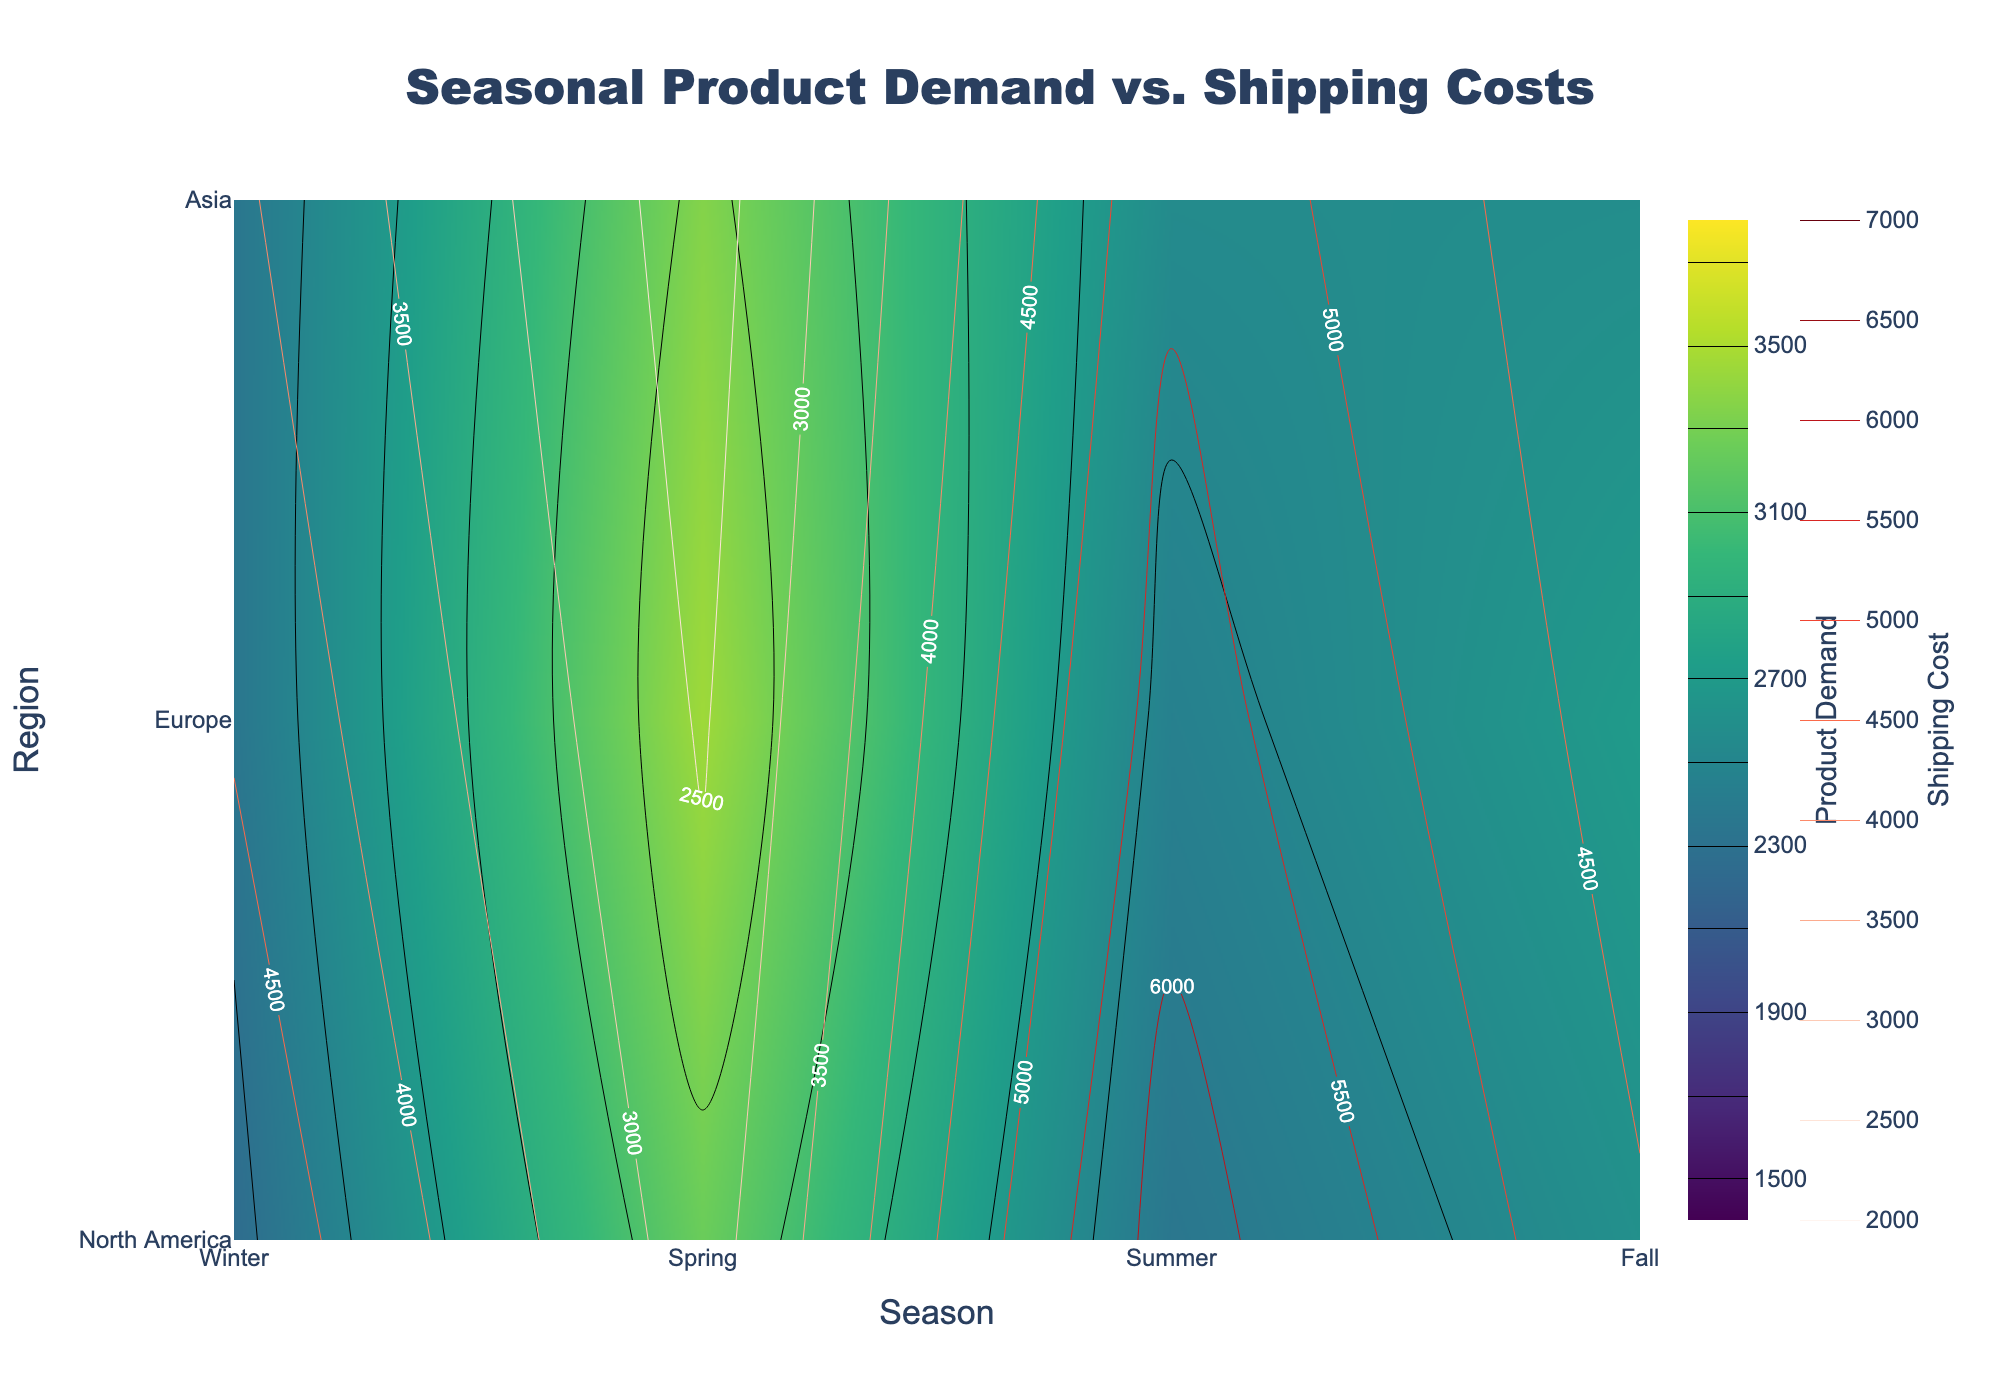What's the title of the figure? The title of the figure is prominently displayed at the top and reads "Seasonal Product Demand vs. Shipping Costs".
Answer: Seasonal Product Demand vs. Shipping Costs Which region shows the highest average product demand in winter? To find the highest average product demand in winter, look at the 'Winter' column and compare the values across regions. Asia shows the highest demand in winter.
Answer: Asia What is the average shipping cost for Europe during spring? To determine the average shipping cost for Europe during spring, find the value in the ‘Spring’ column for the ‘Europe’ row in the contour plot representing shipping costs. The average shipping cost is 2450.
Answer: 2450 Which season has the lowest product demand in North America? Look at the 'North America' row and compare the product demand values across all seasons. Summer has the lowest product demand.
Answer: Summer Compare the average product demand in Asia during winter and summer. Which is higher? Locate the 'Asia' row and compare the product demands during winter and summer. The winter demand (2350) is higher than the summer demand (2550).
Answer: Winter What are the contour line intervals for shipping costs on the plot? Refer to the contour plot details for shipping costs; lines are drawn at intervals of 500 units, starting from 2000 up to 7000.
Answer: 500 units During which season and in which region is the product demand the lowest? Examine the entire contour plot for product demand. The lowest value is during summer in North America, with a demand of 1500.
Answer: Summer in North America Compare and contrast the product demand for ‘Outdoor Furniture’ in Europe during spring with ‘Leaf Blowers’ in North America during fall. Which one is higher? Locate the relevant cells: 'Outdoor Furniture' in Europe during spring and 'Leaf Blowers' in North America during fall. ‘Outdoor Furniture’ has a higher demand (3700) compared to ‘Leaf Blowers’ (2700).
Answer: Outdoor Furniture in Europe during spring Is there any season where the shipping costs are uniformly high across all regions? Check each season to see if shipping costs are high (closer to 7000) for all regions. Summer shows higher and consistent shipping costs across North America, Europe, and Asia, all above 6000.
Answer: Summer 